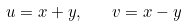<formula> <loc_0><loc_0><loc_500><loc_500>u = x + y , \quad v = x - y</formula> 